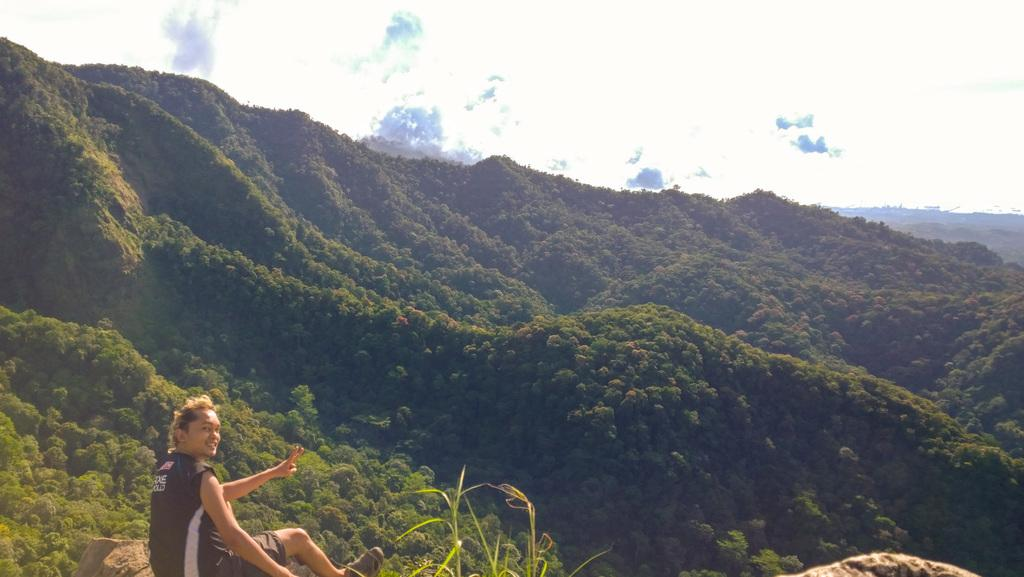What is the woman doing in the image? The woman is sitting on a rock in the image. What is located near the woman? There are plants beside the woman. What can be seen in the background of the image? There are trees on the hills and clouds in the sky in the background of the image. What is the name of the coach driving the woman in the image? There is no coach or vehicle present in the image, so it is not possible to determine the name of a coach. 